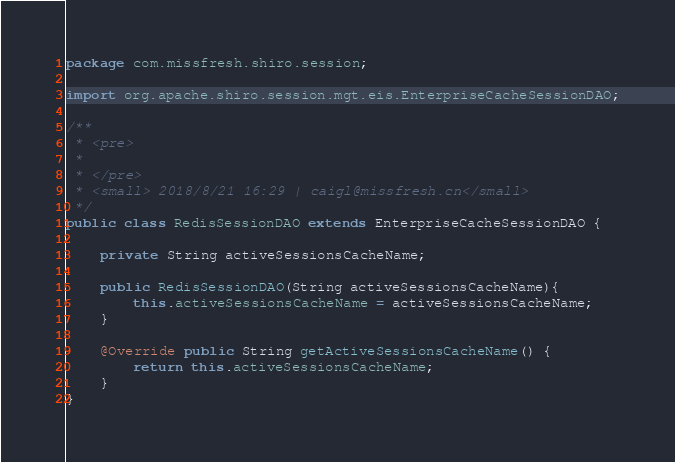<code> <loc_0><loc_0><loc_500><loc_500><_Java_>package com.missfresh.shiro.session;

import org.apache.shiro.session.mgt.eis.EnterpriseCacheSessionDAO;

/**
 * <pre>
 *
 * </pre>
 * <small> 2018/8/21 16:29 | caigl@missfresh.cn</small>
 */
public class RedisSessionDAO extends EnterpriseCacheSessionDAO {

    private String activeSessionsCacheName;

    public RedisSessionDAO(String activeSessionsCacheName){
        this.activeSessionsCacheName = activeSessionsCacheName;
    }

    @Override public String getActiveSessionsCacheName() {
        return this.activeSessionsCacheName;
    }
}
</code> 